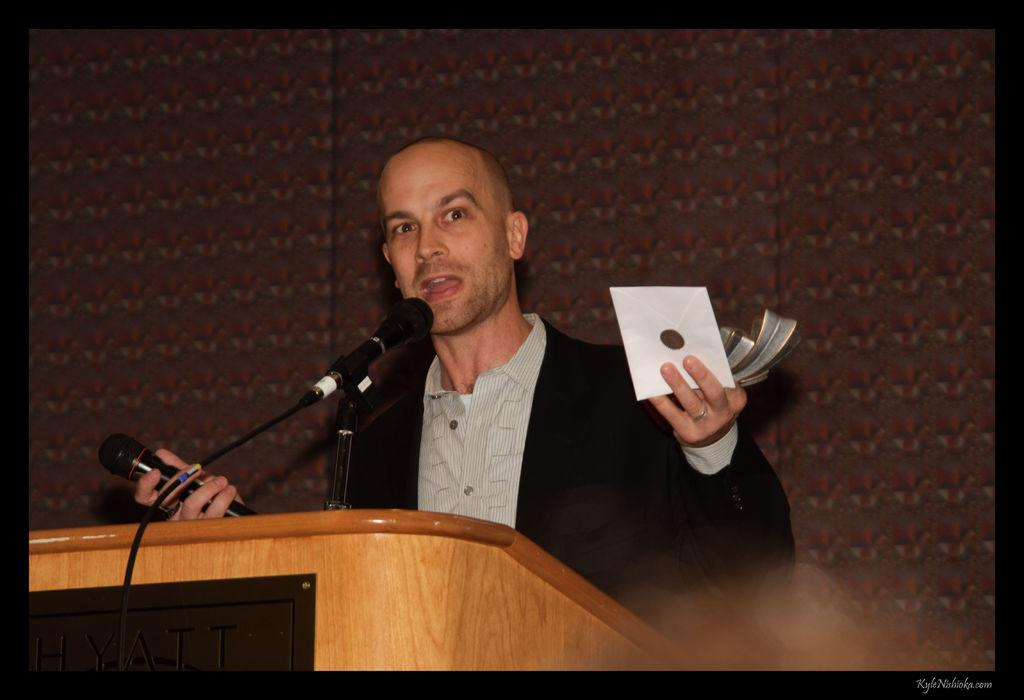What is the main subject of the image? The main subject of the image is a man. What is the man doing in the image? The man is standing and speaking with the help of a microphone. Can you describe the man's actions in more detail? The man holds another microphone in his hand, which suggests he might be using it to speak as well. What object is present in the image that the man might be using for support? There is a podium in the image that the man might be using for support. What type of brick is the man using to drive in the image? There is no brick or driving activity present in the image. The man is using microphones to speak and is standing near a podium. 